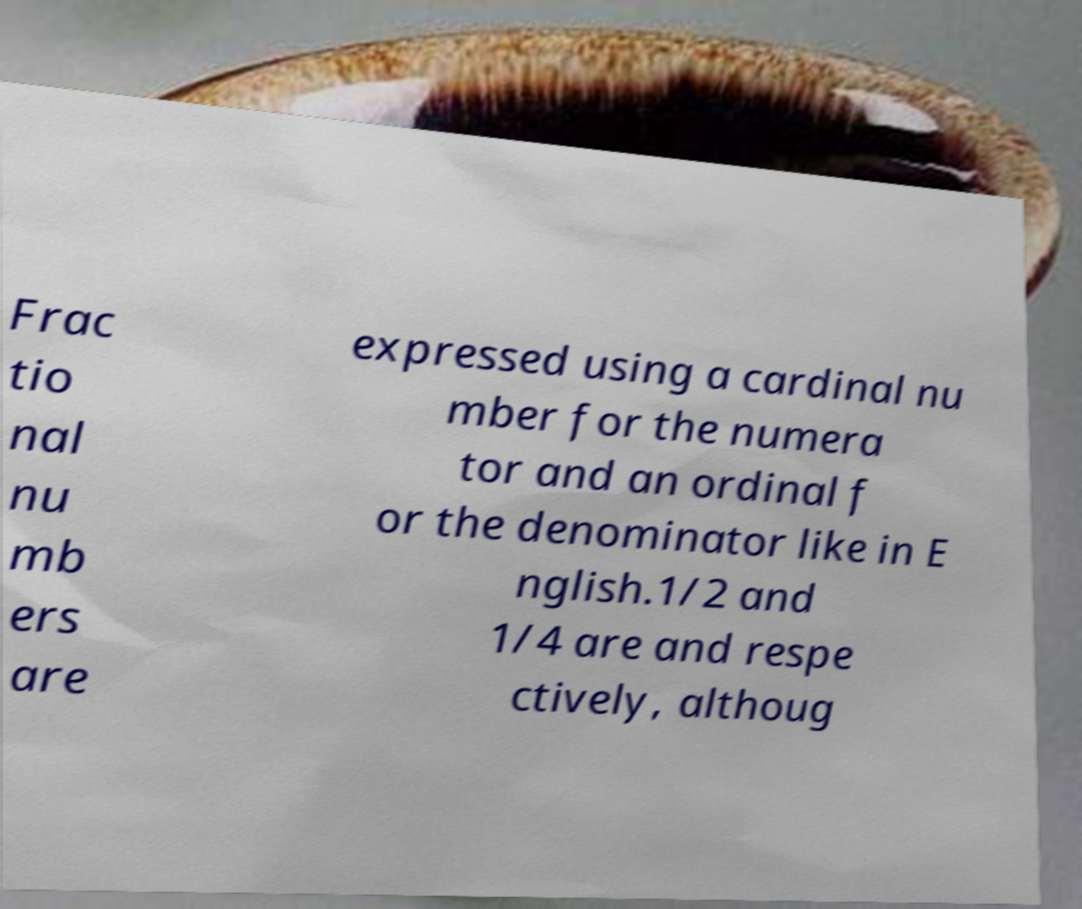Could you extract and type out the text from this image? Frac tio nal nu mb ers are expressed using a cardinal nu mber for the numera tor and an ordinal f or the denominator like in E nglish.1/2 and 1/4 are and respe ctively, althoug 